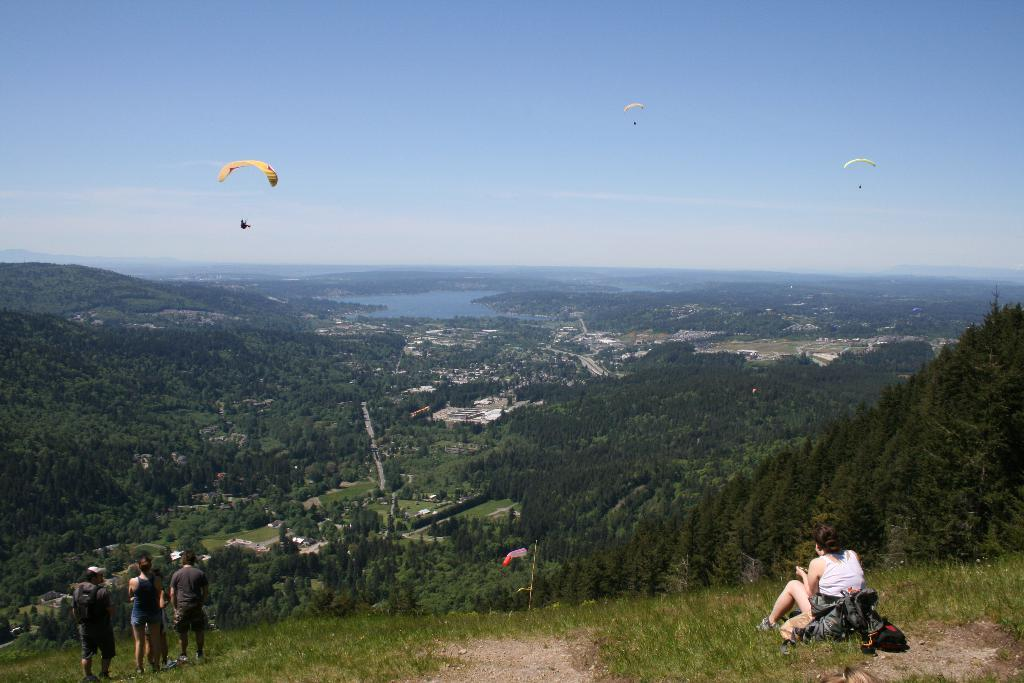What type of natural features can be seen in the image? There are trees and mountains visible in the image. What body of water can be seen in the image? There is water visible in the image. What are the people in the image doing? There are parachutes in the image, suggesting that the people are skydiving or parachuting. What type of structures are present in the image? There are houses in the image. What items are being carried by the people in the image? There are bags in the image, which the people might be using to carry personal belongings. Can you describe the position of one of the people in the image? There is a person sitting in the image. What type of stamp can be seen on the person's forehead in the image? There is no stamp visible on anyone's forehead in the image. How does the bun react to the twist in the image? There is no bun or twist present in the image. 